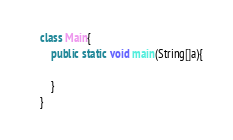<code> <loc_0><loc_0><loc_500><loc_500><_Java_>class Main{
    public static void main(String[]a){

    }
}</code> 